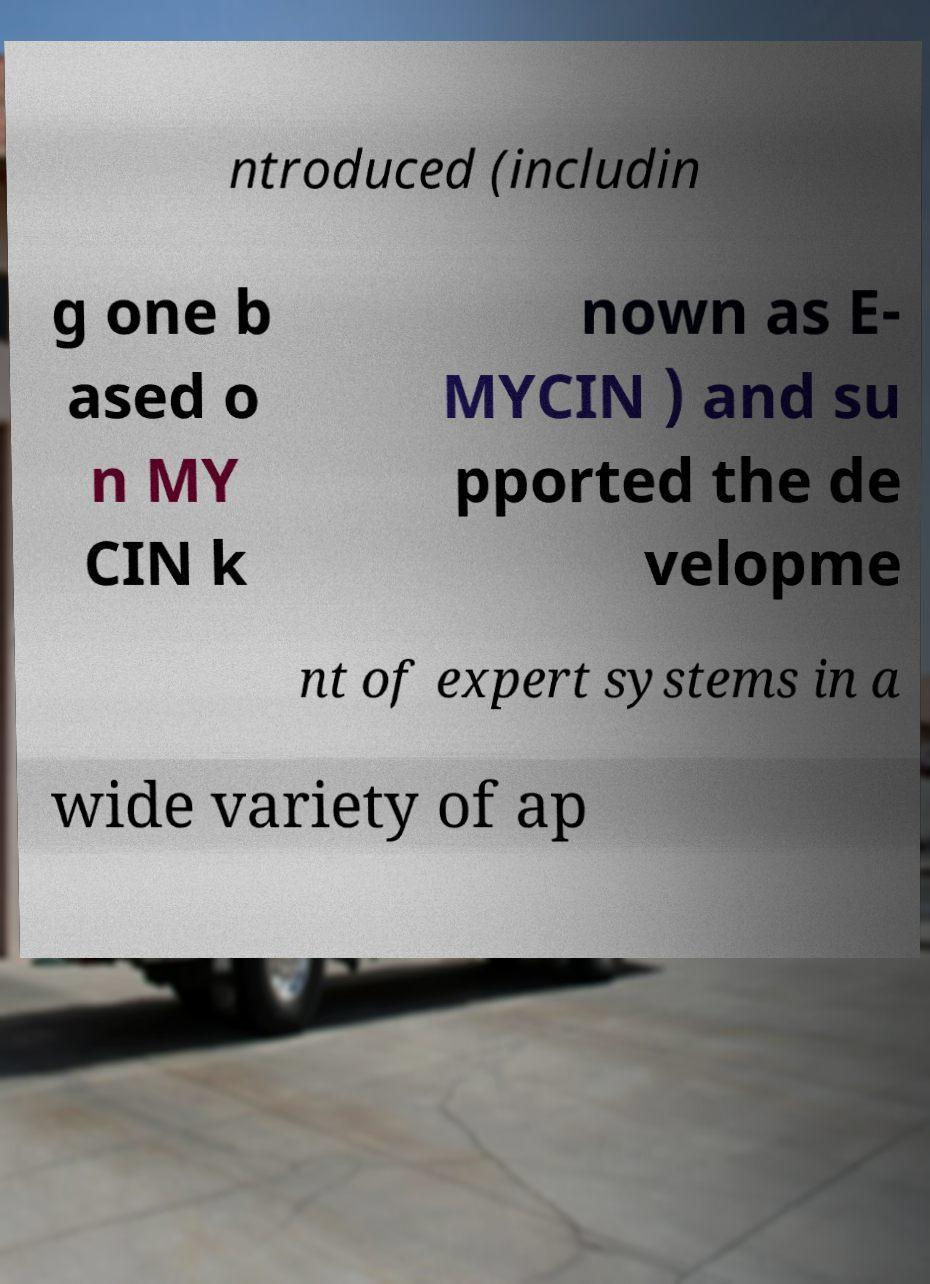Please identify and transcribe the text found in this image. ntroduced (includin g one b ased o n MY CIN k nown as E- MYCIN ) and su pported the de velopme nt of expert systems in a wide variety of ap 